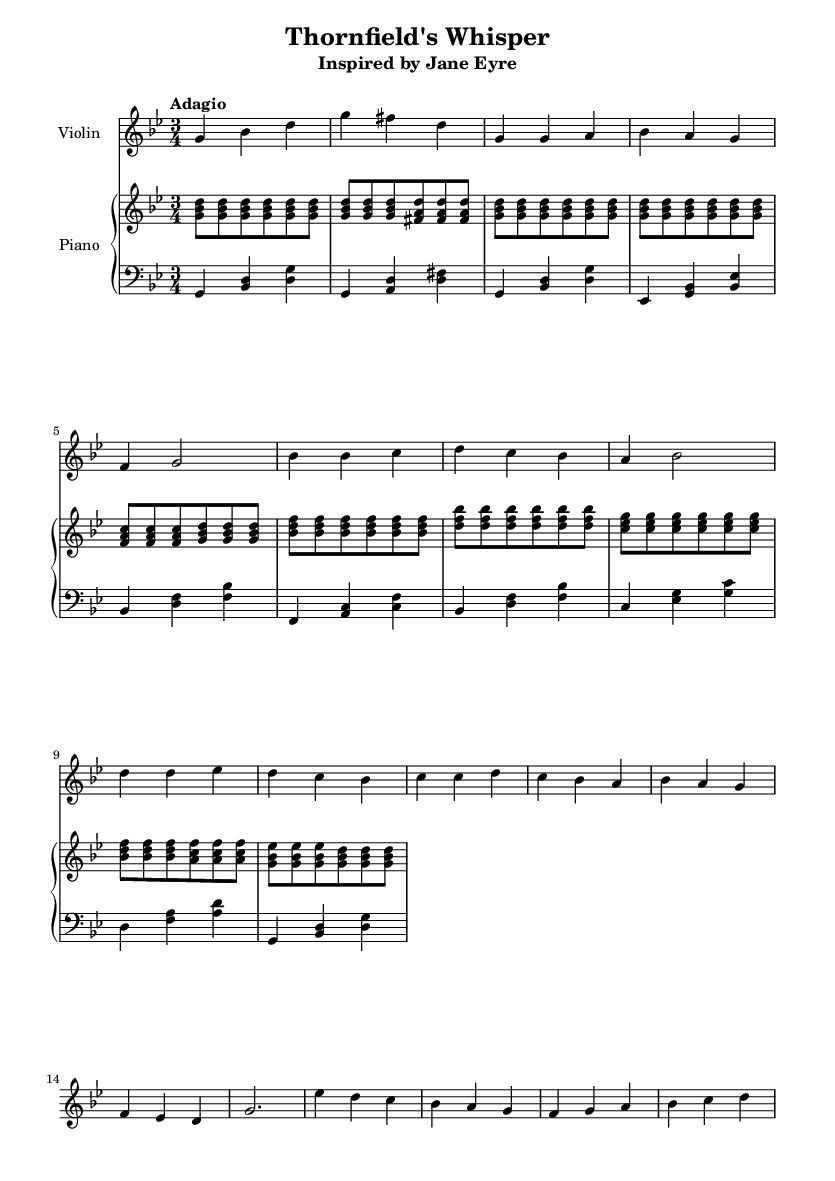What is the key signature of this music? The key signature is G minor, indicated by two flats, B flat and E flat.
Answer: G minor What is the time signature of this piece? The time signature is 3/4, which is shown at the beginning of the score. This means there are three beats per measure and a quarter note gets one beat.
Answer: 3/4 What is the tempo marking for the piece? The tempo marking is "Adagio," which signifies a slow and leisurely pace for the music.
Answer: Adagio How many measures are in the introduction? The introduction contains two measures, which is evident from the notation following the introductory section.
Answer: 2 What is the structure of the piece? The piece is structured into an Introduction, Verse, Chorus, and a Bridge, as labeled through the headings of each section in the music.
Answer: Introduction, Verse, Chorus, Bridge Which instruments are featured in this score? The score features a Violin and a Piano, indicated by the instrument names at the start of each staff.
Answer: Violin and Piano What characterizes the romantic style in this ballad? The piece employs expressive melodies and rich harmonies, typical of Romantic music, evident in the flowing violin lines and the lush piano accompaniments.
Answer: Expressive melodies and rich harmonies 